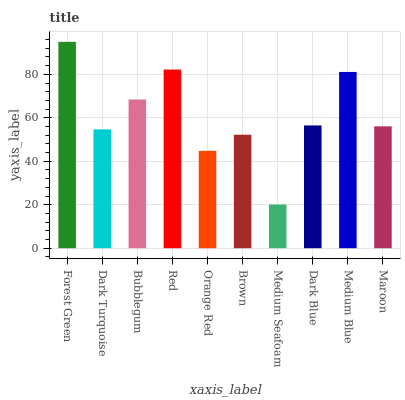Is Medium Seafoam the minimum?
Answer yes or no. Yes. Is Forest Green the maximum?
Answer yes or no. Yes. Is Dark Turquoise the minimum?
Answer yes or no. No. Is Dark Turquoise the maximum?
Answer yes or no. No. Is Forest Green greater than Dark Turquoise?
Answer yes or no. Yes. Is Dark Turquoise less than Forest Green?
Answer yes or no. Yes. Is Dark Turquoise greater than Forest Green?
Answer yes or no. No. Is Forest Green less than Dark Turquoise?
Answer yes or no. No. Is Dark Blue the high median?
Answer yes or no. Yes. Is Maroon the low median?
Answer yes or no. Yes. Is Brown the high median?
Answer yes or no. No. Is Bubblegum the low median?
Answer yes or no. No. 